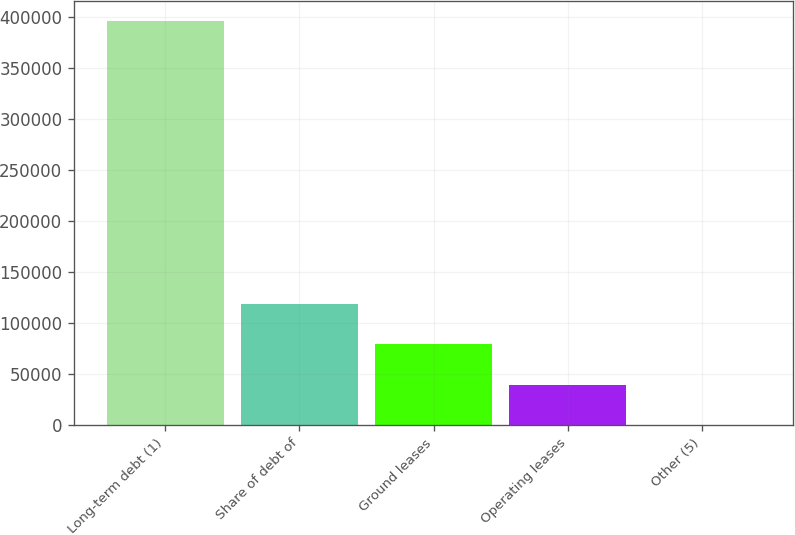Convert chart. <chart><loc_0><loc_0><loc_500><loc_500><bar_chart><fcel>Long-term debt (1)<fcel>Share of debt of<fcel>Ground leases<fcel>Operating leases<fcel>Other (5)<nl><fcel>395988<fcel>118858<fcel>79268<fcel>39678<fcel>88<nl></chart> 